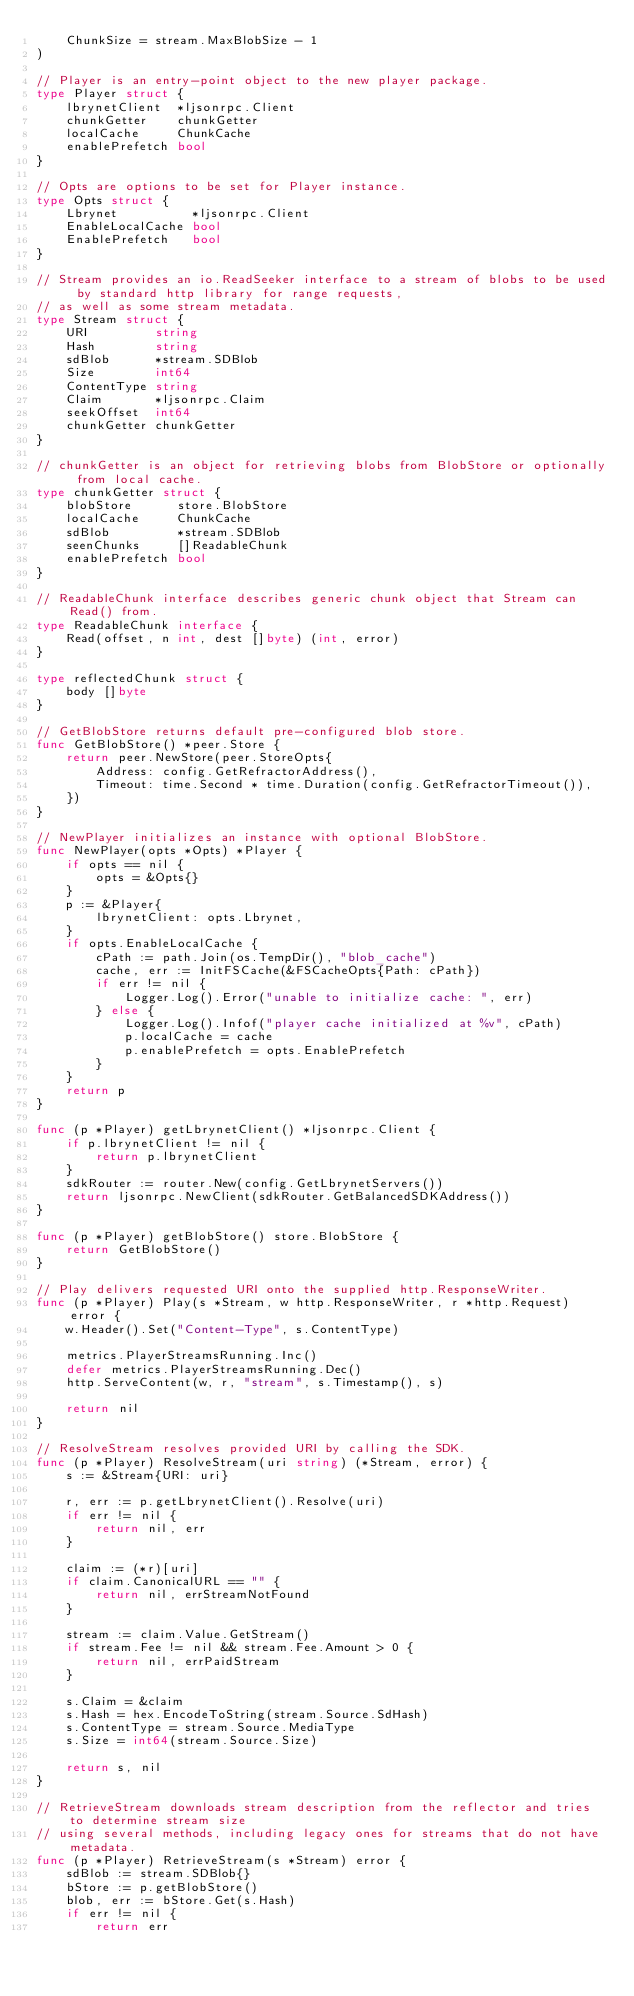<code> <loc_0><loc_0><loc_500><loc_500><_Go_>	ChunkSize = stream.MaxBlobSize - 1
)

// Player is an entry-point object to the new player package.
type Player struct {
	lbrynetClient  *ljsonrpc.Client
	chunkGetter    chunkGetter
	localCache     ChunkCache
	enablePrefetch bool
}

// Opts are options to be set for Player instance.
type Opts struct {
	Lbrynet          *ljsonrpc.Client
	EnableLocalCache bool
	EnablePrefetch   bool
}

// Stream provides an io.ReadSeeker interface to a stream of blobs to be used by standard http library for range requests,
// as well as some stream metadata.
type Stream struct {
	URI         string
	Hash        string
	sdBlob      *stream.SDBlob
	Size        int64
	ContentType string
	Claim       *ljsonrpc.Claim
	seekOffset  int64
	chunkGetter chunkGetter
}

// chunkGetter is an object for retrieving blobs from BlobStore or optionally from local cache.
type chunkGetter struct {
	blobStore      store.BlobStore
	localCache     ChunkCache
	sdBlob         *stream.SDBlob
	seenChunks     []ReadableChunk
	enablePrefetch bool
}

// ReadableChunk interface describes generic chunk object that Stream can Read() from.
type ReadableChunk interface {
	Read(offset, n int, dest []byte) (int, error)
}

type reflectedChunk struct {
	body []byte
}

// GetBlobStore returns default pre-configured blob store.
func GetBlobStore() *peer.Store {
	return peer.NewStore(peer.StoreOpts{
		Address: config.GetRefractorAddress(),
		Timeout: time.Second * time.Duration(config.GetRefractorTimeout()),
	})
}

// NewPlayer initializes an instance with optional BlobStore.
func NewPlayer(opts *Opts) *Player {
	if opts == nil {
		opts = &Opts{}
	}
	p := &Player{
		lbrynetClient: opts.Lbrynet,
	}
	if opts.EnableLocalCache {
		cPath := path.Join(os.TempDir(), "blob_cache")
		cache, err := InitFSCache(&FSCacheOpts{Path: cPath})
		if err != nil {
			Logger.Log().Error("unable to initialize cache: ", err)
		} else {
			Logger.Log().Infof("player cache initialized at %v", cPath)
			p.localCache = cache
			p.enablePrefetch = opts.EnablePrefetch
		}
	}
	return p
}

func (p *Player) getLbrynetClient() *ljsonrpc.Client {
	if p.lbrynetClient != nil {
		return p.lbrynetClient
	}
	sdkRouter := router.New(config.GetLbrynetServers())
	return ljsonrpc.NewClient(sdkRouter.GetBalancedSDKAddress())
}

func (p *Player) getBlobStore() store.BlobStore {
	return GetBlobStore()
}

// Play delivers requested URI onto the supplied http.ResponseWriter.
func (p *Player) Play(s *Stream, w http.ResponseWriter, r *http.Request) error {
	w.Header().Set("Content-Type", s.ContentType)

	metrics.PlayerStreamsRunning.Inc()
	defer metrics.PlayerStreamsRunning.Dec()
	http.ServeContent(w, r, "stream", s.Timestamp(), s)

	return nil
}

// ResolveStream resolves provided URI by calling the SDK.
func (p *Player) ResolveStream(uri string) (*Stream, error) {
	s := &Stream{URI: uri}

	r, err := p.getLbrynetClient().Resolve(uri)
	if err != nil {
		return nil, err
	}

	claim := (*r)[uri]
	if claim.CanonicalURL == "" {
		return nil, errStreamNotFound
	}

	stream := claim.Value.GetStream()
	if stream.Fee != nil && stream.Fee.Amount > 0 {
		return nil, errPaidStream
	}

	s.Claim = &claim
	s.Hash = hex.EncodeToString(stream.Source.SdHash)
	s.ContentType = stream.Source.MediaType
	s.Size = int64(stream.Source.Size)

	return s, nil
}

// RetrieveStream downloads stream description from the reflector and tries to determine stream size
// using several methods, including legacy ones for streams that do not have metadata.
func (p *Player) RetrieveStream(s *Stream) error {
	sdBlob := stream.SDBlob{}
	bStore := p.getBlobStore()
	blob, err := bStore.Get(s.Hash)
	if err != nil {
		return err</code> 